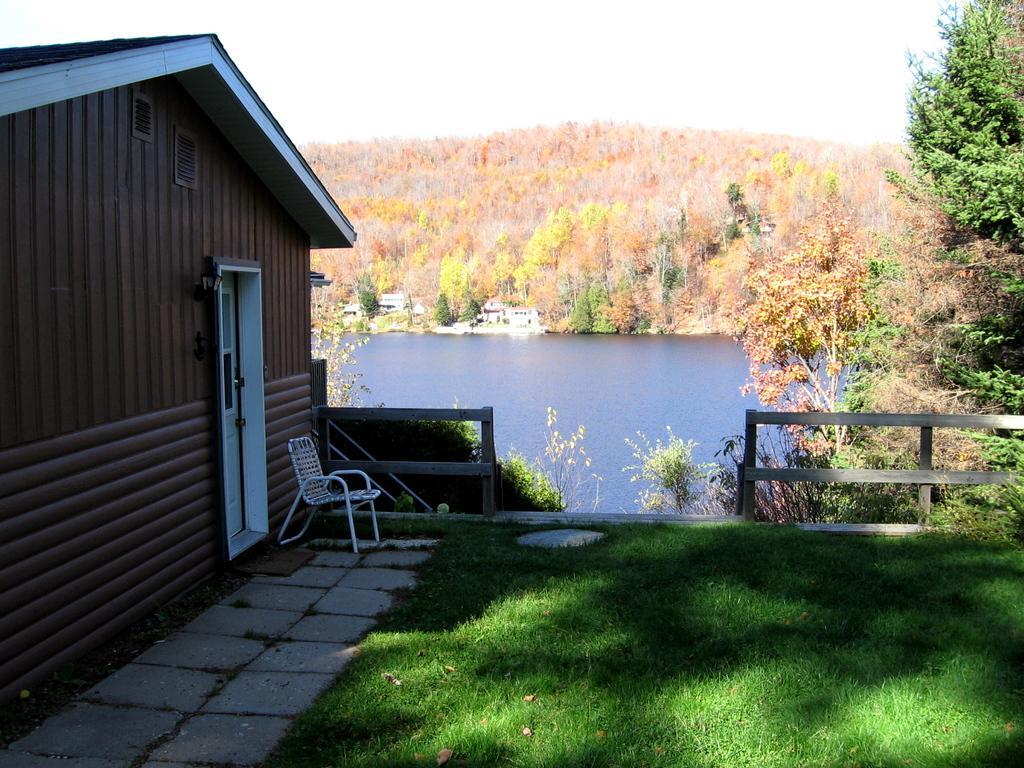How would you summarize this image in a sentence or two? At the bottom of the image there is grass on the surface. At the left side of the image there is a building. In front of the building there is a chair. Beside the building there is a wooden fence. At the center of the image there is water. In the background there are buildings, trees and sky. 